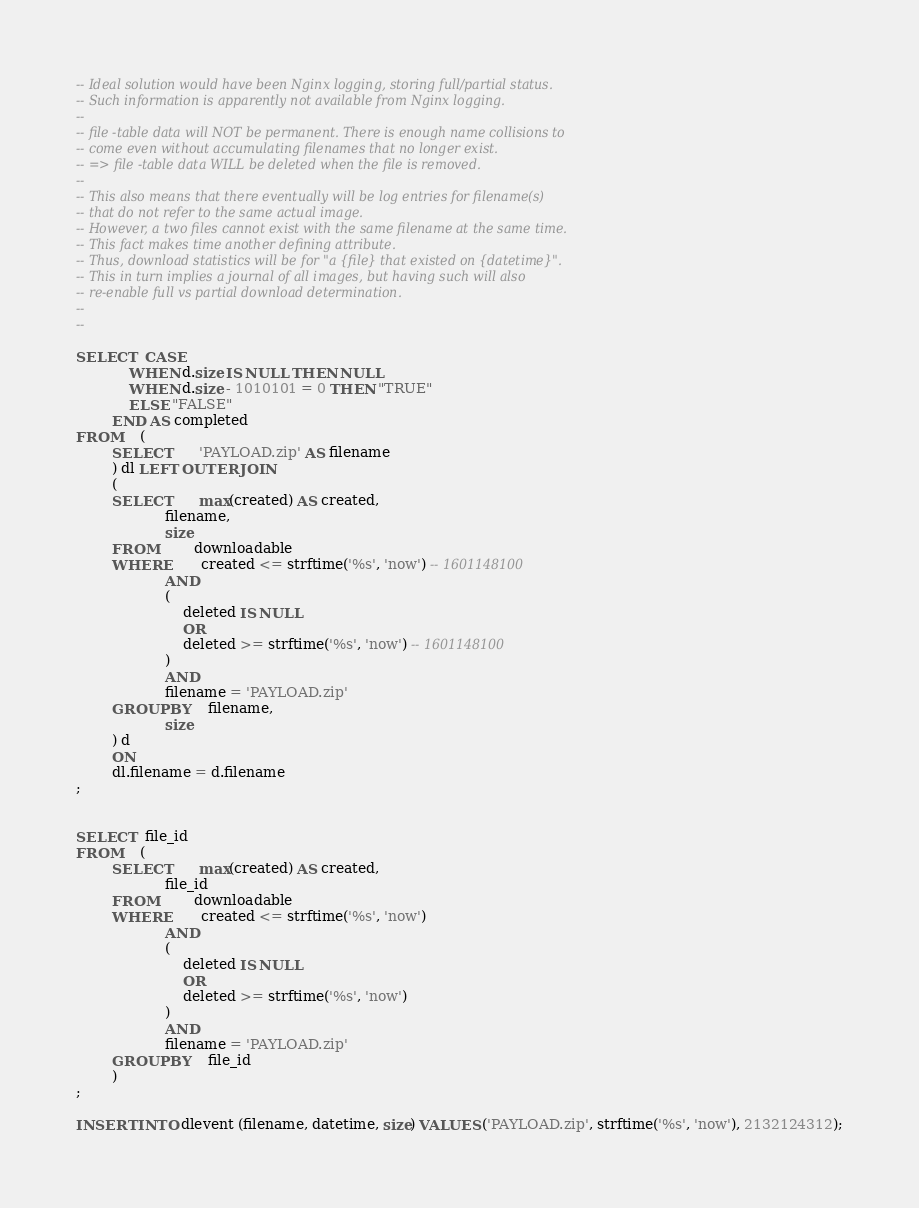Convert code to text. <code><loc_0><loc_0><loc_500><loc_500><_SQL_>




-- Ideal solution would have been Nginx logging, storing full/partial status.
-- Such information is apparently not available from Nginx logging.
--
-- file -table data will NOT be permanent. There is enough name collisions to
-- come even without accumulating filenames that no longer exist.
-- => file -table data WILL be deleted when the file is removed.
--
-- This also means that there eventually will be log entries for filename(s)
-- that do not refer to the same actual image.
-- However, a two files cannot exist with the same filename at the same time.
-- This fact makes time another defining attribute.
-- Thus, download statistics will be for "a {file} that existed on {datetime}".
-- This in turn implies a journal of all images, but having such will also
-- re-enable full vs partial download determination.
--
-- 

SELECT  CASE
            WHEN d.size IS NULL THEN NULL
            WHEN d.size - 1010101 = 0 THEN "TRUE"
            ELSE "FALSE"
        END AS completed
FROM    (
        SELECT      'PAYLOAD.zip' AS filename
        ) dl LEFT OUTER JOIN
        (
        SELECT      max(created) AS created,
                    filename,
                    size
        FROM        downloadable
        WHERE       created <= strftime('%s', 'now') -- 1601148100
                    AND
                    (
                        deleted IS NULL
                        OR
                        deleted >= strftime('%s', 'now') -- 1601148100
                    )
                    AND
                    filename = 'PAYLOAD.zip'
        GROUP BY    filename,
                    size
        ) d
        ON
        dl.filename = d.filename
;


SELECT  file_id
FROM    (
        SELECT      max(created) AS created,
                    file_id
        FROM        downloadable
        WHERE       created <= strftime('%s', 'now')
                    AND
                    (
                        deleted IS NULL
                        OR
                        deleted >= strftime('%s', 'now')
                    )
                    AND
                    filename = 'PAYLOAD.zip'
        GROUP BY    file_id
        )
;

INSERT INTO dlevent (filename, datetime, size) VALUES ('PAYLOAD.zip', strftime('%s', 'now'), 2132124312);

</code> 